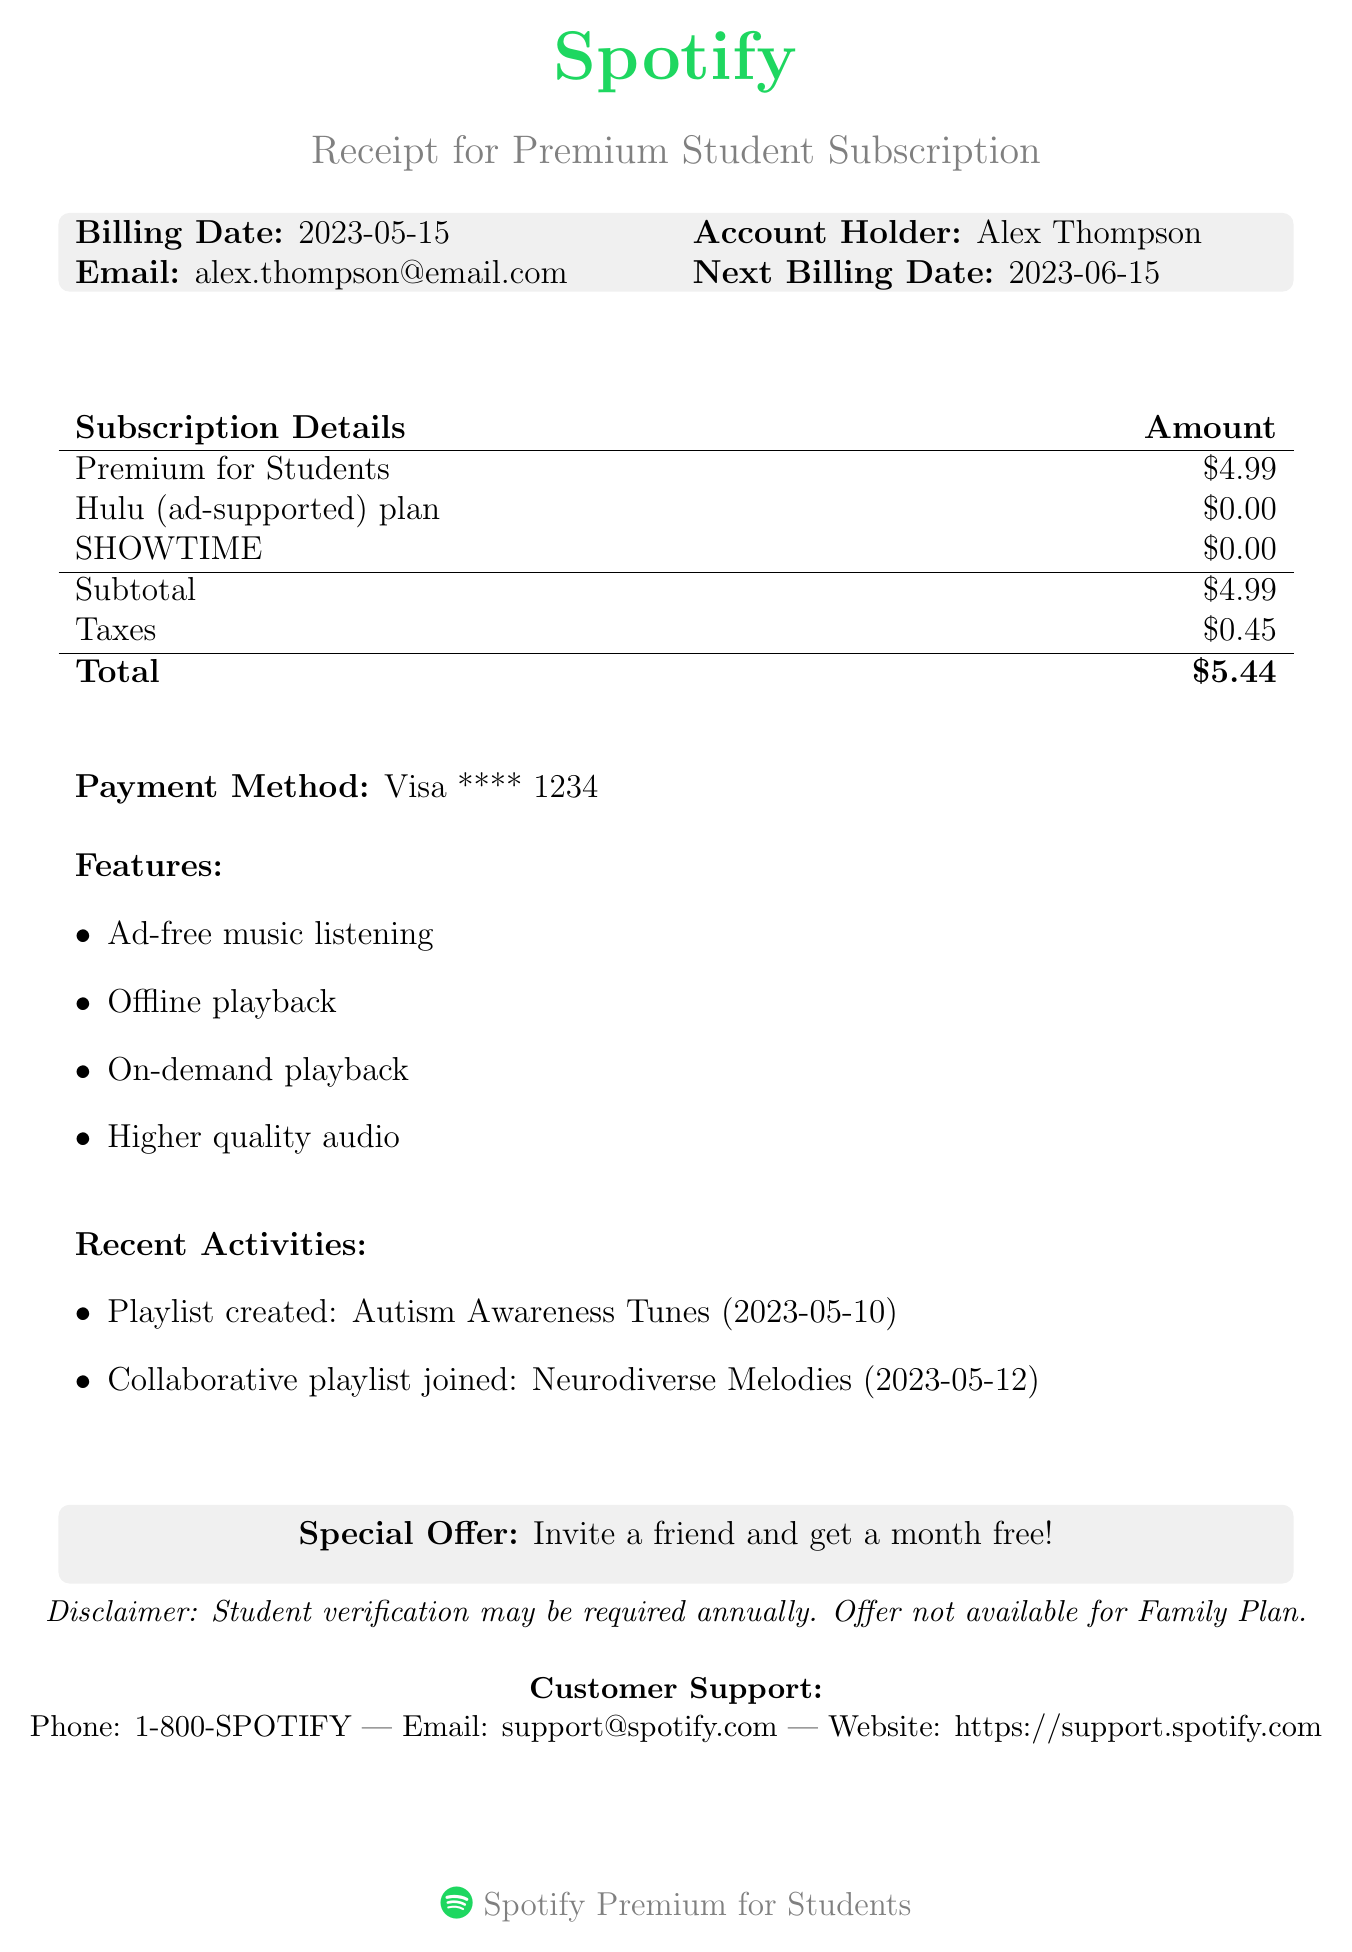What is the subscription type? The subscription type is specified in the document, which is "Premium for Students."
Answer: Premium for Students What is the monthly fee? The monthly fee is clearly stated in the document as "$4.99."
Answer: $4.99 What is the total amount? The total amount is mentioned at the end of the receipt, which includes fees and taxes: "$5.44."
Answer: $5.44 What is the next billing date? The next billing date is listed in the document, which is "2023-06-15."
Answer: 2023-06-15 What feature allows for listening without interruptions? The document lists various features, one of which allows for listening without advertisements: "Ad-free music listening."
Answer: Ad-free music listening What add-on plans are included in the subscription? The document lists add-ons included, which are the "Hulu (ad-supported) plan" and "SHOWTIME."
Answer: Hulu (ad-supported) plan, SHOWTIME Who is the account holder? The account holder's name is specified in the document as "Alex Thompson."
Answer: Alex Thompson What recent activity involved creating a playlist? The document mentions a specific activity where a playlist was created, including its name and date: "Autism Awareness Tunes on 2023-05-10."
Answer: Autism Awareness Tunes What is the special offer mentioned? The receipt includes a special offer that encourages inviting friends: "Invite a friend and get a month free!"
Answer: Invite a friend and get a month free! 